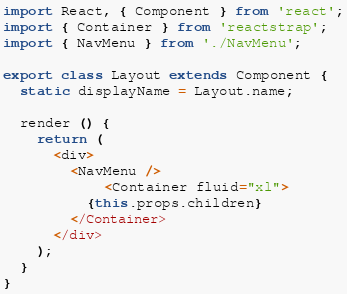Convert code to text. <code><loc_0><loc_0><loc_500><loc_500><_JavaScript_>import React, { Component } from 'react';
import { Container } from 'reactstrap';
import { NavMenu } from './NavMenu';

export class Layout extends Component {
  static displayName = Layout.name;

  render () {
    return (
      <div>
        <NavMenu />
            <Container fluid="xl">
          {this.props.children}
        </Container>
      </div>
    );
  }
}
</code> 